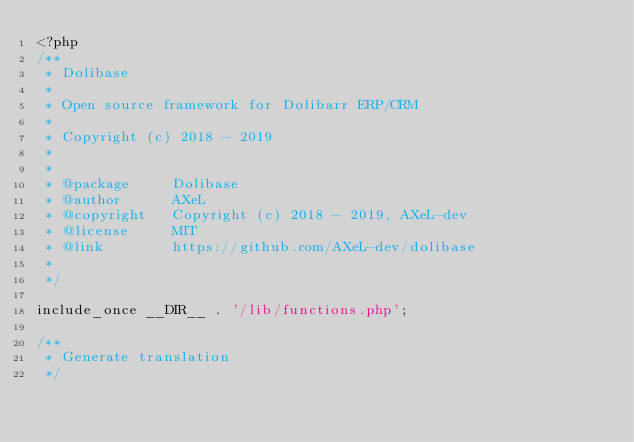Convert code to text. <code><loc_0><loc_0><loc_500><loc_500><_PHP_><?php
/**
 * Dolibase
 * 
 * Open source framework for Dolibarr ERP/CRM
 *
 * Copyright (c) 2018 - 2019
 *
 *
 * @package     Dolibase
 * @author      AXeL
 * @copyright   Copyright (c) 2018 - 2019, AXeL-dev
 * @license     MIT
 * @link        https://github.com/AXeL-dev/dolibase
 * 
 */

include_once __DIR__ . '/lib/functions.php';

/**
 * Generate translation
 */
</code> 